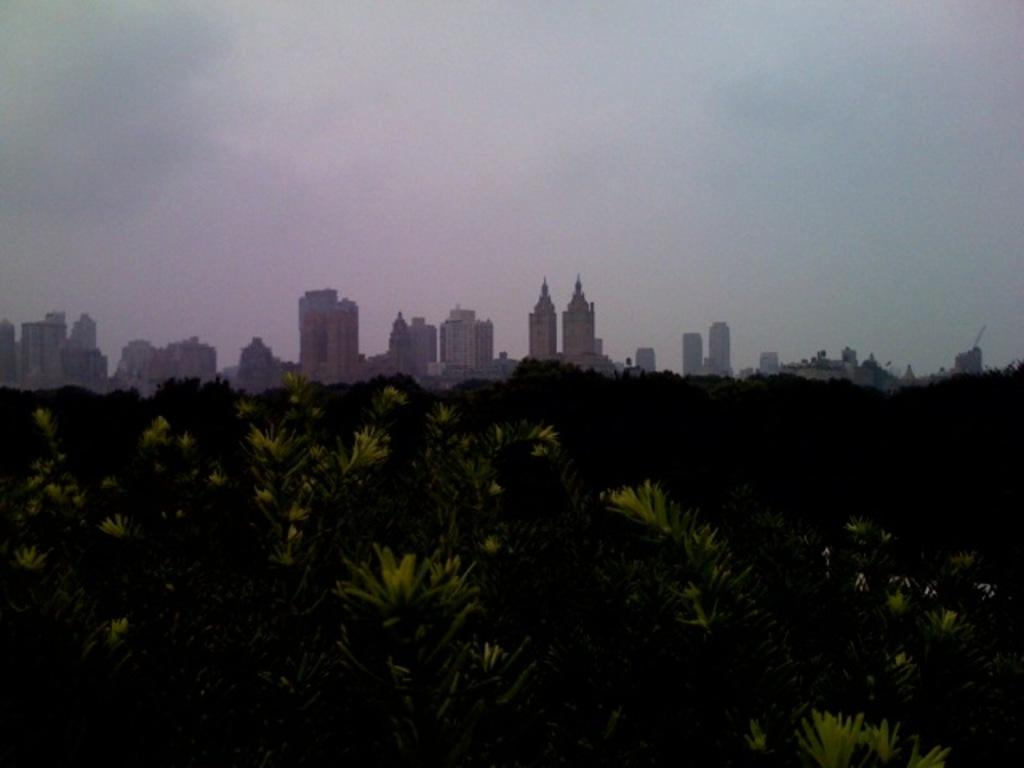What type of vegetation can be seen in the image? There are trees in the image. What type of man-made structures are present in the image? There are buildings in the image. What part of the natural environment is visible in the image? The sky is visible in the image. What type of beds can be seen in the image? There are no beds present in the image. What type of muscle can be seen in the image? There is no muscle present in the image. 